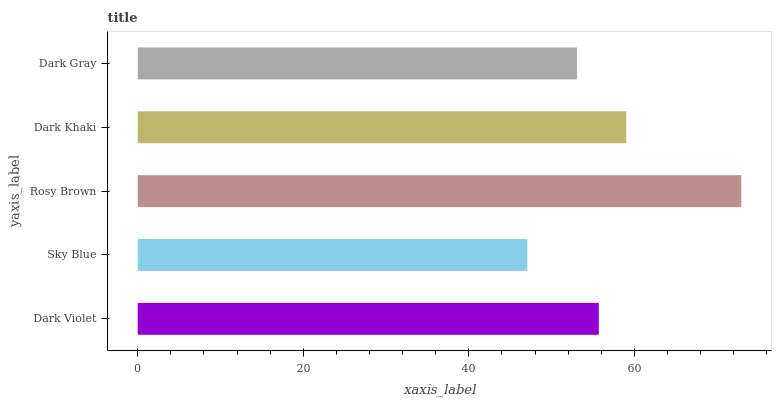Is Sky Blue the minimum?
Answer yes or no. Yes. Is Rosy Brown the maximum?
Answer yes or no. Yes. Is Rosy Brown the minimum?
Answer yes or no. No. Is Sky Blue the maximum?
Answer yes or no. No. Is Rosy Brown greater than Sky Blue?
Answer yes or no. Yes. Is Sky Blue less than Rosy Brown?
Answer yes or no. Yes. Is Sky Blue greater than Rosy Brown?
Answer yes or no. No. Is Rosy Brown less than Sky Blue?
Answer yes or no. No. Is Dark Violet the high median?
Answer yes or no. Yes. Is Dark Violet the low median?
Answer yes or no. Yes. Is Dark Gray the high median?
Answer yes or no. No. Is Rosy Brown the low median?
Answer yes or no. No. 